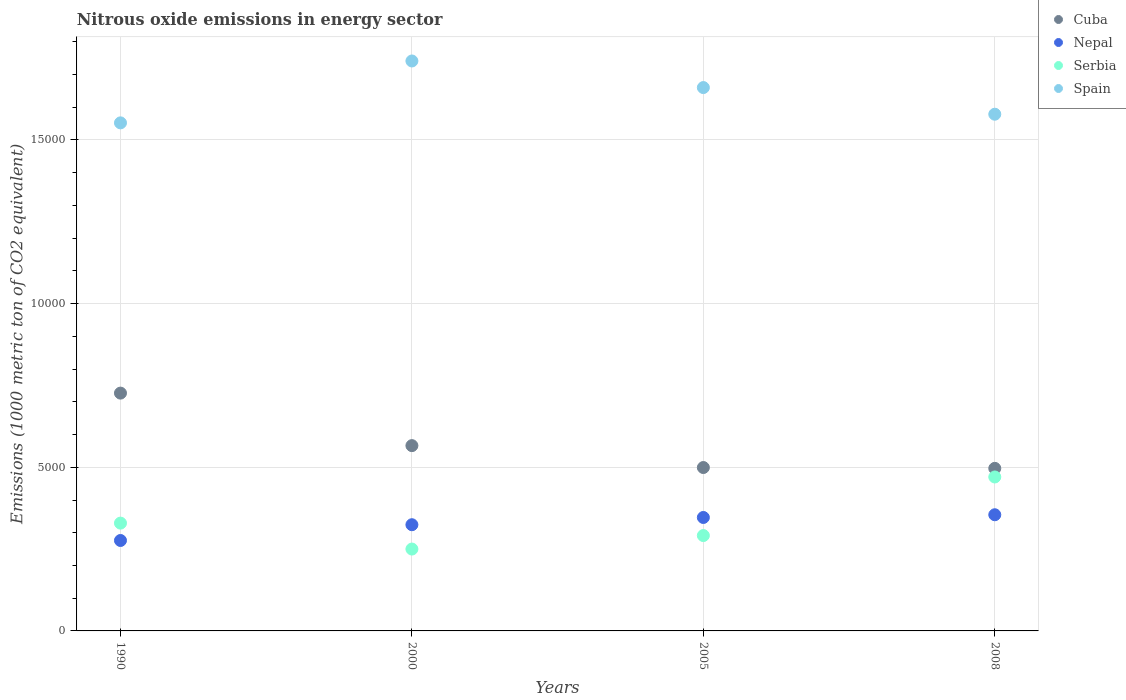How many different coloured dotlines are there?
Provide a succinct answer. 4. What is the amount of nitrous oxide emitted in Spain in 2000?
Your response must be concise. 1.74e+04. Across all years, what is the maximum amount of nitrous oxide emitted in Nepal?
Your response must be concise. 3549.4. Across all years, what is the minimum amount of nitrous oxide emitted in Nepal?
Your answer should be very brief. 2763. In which year was the amount of nitrous oxide emitted in Cuba maximum?
Ensure brevity in your answer.  1990. What is the total amount of nitrous oxide emitted in Cuba in the graph?
Offer a very short reply. 2.29e+04. What is the difference between the amount of nitrous oxide emitted in Serbia in 1990 and that in 2005?
Ensure brevity in your answer.  380. What is the difference between the amount of nitrous oxide emitted in Serbia in 2000 and the amount of nitrous oxide emitted in Spain in 2008?
Ensure brevity in your answer.  -1.33e+04. What is the average amount of nitrous oxide emitted in Serbia per year?
Give a very brief answer. 3353.15. In the year 2008, what is the difference between the amount of nitrous oxide emitted in Nepal and amount of nitrous oxide emitted in Spain?
Provide a succinct answer. -1.22e+04. In how many years, is the amount of nitrous oxide emitted in Nepal greater than 4000 1000 metric ton?
Ensure brevity in your answer.  0. What is the ratio of the amount of nitrous oxide emitted in Cuba in 2000 to that in 2005?
Your answer should be very brief. 1.13. What is the difference between the highest and the second highest amount of nitrous oxide emitted in Spain?
Provide a succinct answer. 812.5. What is the difference between the highest and the lowest amount of nitrous oxide emitted in Cuba?
Provide a succinct answer. 2298.9. In how many years, is the amount of nitrous oxide emitted in Serbia greater than the average amount of nitrous oxide emitted in Serbia taken over all years?
Your answer should be very brief. 1. Is it the case that in every year, the sum of the amount of nitrous oxide emitted in Cuba and amount of nitrous oxide emitted in Spain  is greater than the sum of amount of nitrous oxide emitted in Nepal and amount of nitrous oxide emitted in Serbia?
Your response must be concise. No. Is the amount of nitrous oxide emitted in Serbia strictly less than the amount of nitrous oxide emitted in Spain over the years?
Give a very brief answer. Yes. How many dotlines are there?
Your answer should be very brief. 4. How many years are there in the graph?
Provide a short and direct response. 4. What is the difference between two consecutive major ticks on the Y-axis?
Provide a short and direct response. 5000. Are the values on the major ticks of Y-axis written in scientific E-notation?
Provide a succinct answer. No. Does the graph contain any zero values?
Your answer should be very brief. No. Does the graph contain grids?
Your answer should be very brief. Yes. How many legend labels are there?
Make the answer very short. 4. How are the legend labels stacked?
Provide a succinct answer. Vertical. What is the title of the graph?
Ensure brevity in your answer.  Nitrous oxide emissions in energy sector. Does "Germany" appear as one of the legend labels in the graph?
Your answer should be very brief. No. What is the label or title of the Y-axis?
Ensure brevity in your answer.  Emissions (1000 metric ton of CO2 equivalent). What is the Emissions (1000 metric ton of CO2 equivalent) in Cuba in 1990?
Make the answer very short. 7265.9. What is the Emissions (1000 metric ton of CO2 equivalent) of Nepal in 1990?
Ensure brevity in your answer.  2763. What is the Emissions (1000 metric ton of CO2 equivalent) of Serbia in 1990?
Offer a terse response. 3293.8. What is the Emissions (1000 metric ton of CO2 equivalent) in Spain in 1990?
Your response must be concise. 1.55e+04. What is the Emissions (1000 metric ton of CO2 equivalent) of Cuba in 2000?
Provide a succinct answer. 5661.3. What is the Emissions (1000 metric ton of CO2 equivalent) in Nepal in 2000?
Keep it short and to the point. 3244.8. What is the Emissions (1000 metric ton of CO2 equivalent) of Serbia in 2000?
Offer a terse response. 2501.4. What is the Emissions (1000 metric ton of CO2 equivalent) in Spain in 2000?
Provide a succinct answer. 1.74e+04. What is the Emissions (1000 metric ton of CO2 equivalent) in Cuba in 2005?
Your answer should be very brief. 4992.1. What is the Emissions (1000 metric ton of CO2 equivalent) in Nepal in 2005?
Provide a succinct answer. 3466.2. What is the Emissions (1000 metric ton of CO2 equivalent) of Serbia in 2005?
Your response must be concise. 2913.8. What is the Emissions (1000 metric ton of CO2 equivalent) in Spain in 2005?
Provide a short and direct response. 1.66e+04. What is the Emissions (1000 metric ton of CO2 equivalent) in Cuba in 2008?
Your answer should be very brief. 4967. What is the Emissions (1000 metric ton of CO2 equivalent) of Nepal in 2008?
Offer a very short reply. 3549.4. What is the Emissions (1000 metric ton of CO2 equivalent) in Serbia in 2008?
Your answer should be very brief. 4703.6. What is the Emissions (1000 metric ton of CO2 equivalent) in Spain in 2008?
Give a very brief answer. 1.58e+04. Across all years, what is the maximum Emissions (1000 metric ton of CO2 equivalent) in Cuba?
Your answer should be compact. 7265.9. Across all years, what is the maximum Emissions (1000 metric ton of CO2 equivalent) in Nepal?
Make the answer very short. 3549.4. Across all years, what is the maximum Emissions (1000 metric ton of CO2 equivalent) of Serbia?
Make the answer very short. 4703.6. Across all years, what is the maximum Emissions (1000 metric ton of CO2 equivalent) in Spain?
Your answer should be compact. 1.74e+04. Across all years, what is the minimum Emissions (1000 metric ton of CO2 equivalent) of Cuba?
Your answer should be very brief. 4967. Across all years, what is the minimum Emissions (1000 metric ton of CO2 equivalent) in Nepal?
Keep it short and to the point. 2763. Across all years, what is the minimum Emissions (1000 metric ton of CO2 equivalent) in Serbia?
Offer a very short reply. 2501.4. Across all years, what is the minimum Emissions (1000 metric ton of CO2 equivalent) in Spain?
Keep it short and to the point. 1.55e+04. What is the total Emissions (1000 metric ton of CO2 equivalent) of Cuba in the graph?
Keep it short and to the point. 2.29e+04. What is the total Emissions (1000 metric ton of CO2 equivalent) in Nepal in the graph?
Ensure brevity in your answer.  1.30e+04. What is the total Emissions (1000 metric ton of CO2 equivalent) of Serbia in the graph?
Make the answer very short. 1.34e+04. What is the total Emissions (1000 metric ton of CO2 equivalent) in Spain in the graph?
Your answer should be compact. 6.53e+04. What is the difference between the Emissions (1000 metric ton of CO2 equivalent) of Cuba in 1990 and that in 2000?
Keep it short and to the point. 1604.6. What is the difference between the Emissions (1000 metric ton of CO2 equivalent) of Nepal in 1990 and that in 2000?
Offer a very short reply. -481.8. What is the difference between the Emissions (1000 metric ton of CO2 equivalent) of Serbia in 1990 and that in 2000?
Ensure brevity in your answer.  792.4. What is the difference between the Emissions (1000 metric ton of CO2 equivalent) in Spain in 1990 and that in 2000?
Your answer should be very brief. -1890.8. What is the difference between the Emissions (1000 metric ton of CO2 equivalent) in Cuba in 1990 and that in 2005?
Your response must be concise. 2273.8. What is the difference between the Emissions (1000 metric ton of CO2 equivalent) in Nepal in 1990 and that in 2005?
Make the answer very short. -703.2. What is the difference between the Emissions (1000 metric ton of CO2 equivalent) in Serbia in 1990 and that in 2005?
Give a very brief answer. 380. What is the difference between the Emissions (1000 metric ton of CO2 equivalent) in Spain in 1990 and that in 2005?
Your answer should be very brief. -1078.3. What is the difference between the Emissions (1000 metric ton of CO2 equivalent) of Cuba in 1990 and that in 2008?
Your answer should be compact. 2298.9. What is the difference between the Emissions (1000 metric ton of CO2 equivalent) of Nepal in 1990 and that in 2008?
Provide a short and direct response. -786.4. What is the difference between the Emissions (1000 metric ton of CO2 equivalent) of Serbia in 1990 and that in 2008?
Provide a short and direct response. -1409.8. What is the difference between the Emissions (1000 metric ton of CO2 equivalent) of Spain in 1990 and that in 2008?
Make the answer very short. -264.1. What is the difference between the Emissions (1000 metric ton of CO2 equivalent) of Cuba in 2000 and that in 2005?
Make the answer very short. 669.2. What is the difference between the Emissions (1000 metric ton of CO2 equivalent) in Nepal in 2000 and that in 2005?
Your answer should be compact. -221.4. What is the difference between the Emissions (1000 metric ton of CO2 equivalent) of Serbia in 2000 and that in 2005?
Make the answer very short. -412.4. What is the difference between the Emissions (1000 metric ton of CO2 equivalent) of Spain in 2000 and that in 2005?
Offer a very short reply. 812.5. What is the difference between the Emissions (1000 metric ton of CO2 equivalent) in Cuba in 2000 and that in 2008?
Offer a terse response. 694.3. What is the difference between the Emissions (1000 metric ton of CO2 equivalent) of Nepal in 2000 and that in 2008?
Provide a short and direct response. -304.6. What is the difference between the Emissions (1000 metric ton of CO2 equivalent) of Serbia in 2000 and that in 2008?
Keep it short and to the point. -2202.2. What is the difference between the Emissions (1000 metric ton of CO2 equivalent) of Spain in 2000 and that in 2008?
Keep it short and to the point. 1626.7. What is the difference between the Emissions (1000 metric ton of CO2 equivalent) of Cuba in 2005 and that in 2008?
Ensure brevity in your answer.  25.1. What is the difference between the Emissions (1000 metric ton of CO2 equivalent) of Nepal in 2005 and that in 2008?
Give a very brief answer. -83.2. What is the difference between the Emissions (1000 metric ton of CO2 equivalent) in Serbia in 2005 and that in 2008?
Your answer should be compact. -1789.8. What is the difference between the Emissions (1000 metric ton of CO2 equivalent) of Spain in 2005 and that in 2008?
Offer a terse response. 814.2. What is the difference between the Emissions (1000 metric ton of CO2 equivalent) in Cuba in 1990 and the Emissions (1000 metric ton of CO2 equivalent) in Nepal in 2000?
Offer a terse response. 4021.1. What is the difference between the Emissions (1000 metric ton of CO2 equivalent) of Cuba in 1990 and the Emissions (1000 metric ton of CO2 equivalent) of Serbia in 2000?
Keep it short and to the point. 4764.5. What is the difference between the Emissions (1000 metric ton of CO2 equivalent) of Cuba in 1990 and the Emissions (1000 metric ton of CO2 equivalent) of Spain in 2000?
Provide a short and direct response. -1.01e+04. What is the difference between the Emissions (1000 metric ton of CO2 equivalent) in Nepal in 1990 and the Emissions (1000 metric ton of CO2 equivalent) in Serbia in 2000?
Give a very brief answer. 261.6. What is the difference between the Emissions (1000 metric ton of CO2 equivalent) in Nepal in 1990 and the Emissions (1000 metric ton of CO2 equivalent) in Spain in 2000?
Provide a short and direct response. -1.47e+04. What is the difference between the Emissions (1000 metric ton of CO2 equivalent) in Serbia in 1990 and the Emissions (1000 metric ton of CO2 equivalent) in Spain in 2000?
Make the answer very short. -1.41e+04. What is the difference between the Emissions (1000 metric ton of CO2 equivalent) of Cuba in 1990 and the Emissions (1000 metric ton of CO2 equivalent) of Nepal in 2005?
Your answer should be very brief. 3799.7. What is the difference between the Emissions (1000 metric ton of CO2 equivalent) of Cuba in 1990 and the Emissions (1000 metric ton of CO2 equivalent) of Serbia in 2005?
Ensure brevity in your answer.  4352.1. What is the difference between the Emissions (1000 metric ton of CO2 equivalent) of Cuba in 1990 and the Emissions (1000 metric ton of CO2 equivalent) of Spain in 2005?
Offer a terse response. -9335.4. What is the difference between the Emissions (1000 metric ton of CO2 equivalent) in Nepal in 1990 and the Emissions (1000 metric ton of CO2 equivalent) in Serbia in 2005?
Your response must be concise. -150.8. What is the difference between the Emissions (1000 metric ton of CO2 equivalent) in Nepal in 1990 and the Emissions (1000 metric ton of CO2 equivalent) in Spain in 2005?
Your answer should be compact. -1.38e+04. What is the difference between the Emissions (1000 metric ton of CO2 equivalent) of Serbia in 1990 and the Emissions (1000 metric ton of CO2 equivalent) of Spain in 2005?
Your answer should be very brief. -1.33e+04. What is the difference between the Emissions (1000 metric ton of CO2 equivalent) of Cuba in 1990 and the Emissions (1000 metric ton of CO2 equivalent) of Nepal in 2008?
Make the answer very short. 3716.5. What is the difference between the Emissions (1000 metric ton of CO2 equivalent) in Cuba in 1990 and the Emissions (1000 metric ton of CO2 equivalent) in Serbia in 2008?
Ensure brevity in your answer.  2562.3. What is the difference between the Emissions (1000 metric ton of CO2 equivalent) of Cuba in 1990 and the Emissions (1000 metric ton of CO2 equivalent) of Spain in 2008?
Your answer should be compact. -8521.2. What is the difference between the Emissions (1000 metric ton of CO2 equivalent) in Nepal in 1990 and the Emissions (1000 metric ton of CO2 equivalent) in Serbia in 2008?
Your answer should be compact. -1940.6. What is the difference between the Emissions (1000 metric ton of CO2 equivalent) of Nepal in 1990 and the Emissions (1000 metric ton of CO2 equivalent) of Spain in 2008?
Provide a succinct answer. -1.30e+04. What is the difference between the Emissions (1000 metric ton of CO2 equivalent) in Serbia in 1990 and the Emissions (1000 metric ton of CO2 equivalent) in Spain in 2008?
Your answer should be compact. -1.25e+04. What is the difference between the Emissions (1000 metric ton of CO2 equivalent) of Cuba in 2000 and the Emissions (1000 metric ton of CO2 equivalent) of Nepal in 2005?
Your response must be concise. 2195.1. What is the difference between the Emissions (1000 metric ton of CO2 equivalent) of Cuba in 2000 and the Emissions (1000 metric ton of CO2 equivalent) of Serbia in 2005?
Your response must be concise. 2747.5. What is the difference between the Emissions (1000 metric ton of CO2 equivalent) of Cuba in 2000 and the Emissions (1000 metric ton of CO2 equivalent) of Spain in 2005?
Offer a terse response. -1.09e+04. What is the difference between the Emissions (1000 metric ton of CO2 equivalent) in Nepal in 2000 and the Emissions (1000 metric ton of CO2 equivalent) in Serbia in 2005?
Your answer should be very brief. 331. What is the difference between the Emissions (1000 metric ton of CO2 equivalent) of Nepal in 2000 and the Emissions (1000 metric ton of CO2 equivalent) of Spain in 2005?
Ensure brevity in your answer.  -1.34e+04. What is the difference between the Emissions (1000 metric ton of CO2 equivalent) of Serbia in 2000 and the Emissions (1000 metric ton of CO2 equivalent) of Spain in 2005?
Keep it short and to the point. -1.41e+04. What is the difference between the Emissions (1000 metric ton of CO2 equivalent) of Cuba in 2000 and the Emissions (1000 metric ton of CO2 equivalent) of Nepal in 2008?
Ensure brevity in your answer.  2111.9. What is the difference between the Emissions (1000 metric ton of CO2 equivalent) of Cuba in 2000 and the Emissions (1000 metric ton of CO2 equivalent) of Serbia in 2008?
Your response must be concise. 957.7. What is the difference between the Emissions (1000 metric ton of CO2 equivalent) in Cuba in 2000 and the Emissions (1000 metric ton of CO2 equivalent) in Spain in 2008?
Give a very brief answer. -1.01e+04. What is the difference between the Emissions (1000 metric ton of CO2 equivalent) in Nepal in 2000 and the Emissions (1000 metric ton of CO2 equivalent) in Serbia in 2008?
Give a very brief answer. -1458.8. What is the difference between the Emissions (1000 metric ton of CO2 equivalent) in Nepal in 2000 and the Emissions (1000 metric ton of CO2 equivalent) in Spain in 2008?
Provide a short and direct response. -1.25e+04. What is the difference between the Emissions (1000 metric ton of CO2 equivalent) in Serbia in 2000 and the Emissions (1000 metric ton of CO2 equivalent) in Spain in 2008?
Provide a short and direct response. -1.33e+04. What is the difference between the Emissions (1000 metric ton of CO2 equivalent) of Cuba in 2005 and the Emissions (1000 metric ton of CO2 equivalent) of Nepal in 2008?
Offer a very short reply. 1442.7. What is the difference between the Emissions (1000 metric ton of CO2 equivalent) of Cuba in 2005 and the Emissions (1000 metric ton of CO2 equivalent) of Serbia in 2008?
Provide a succinct answer. 288.5. What is the difference between the Emissions (1000 metric ton of CO2 equivalent) in Cuba in 2005 and the Emissions (1000 metric ton of CO2 equivalent) in Spain in 2008?
Give a very brief answer. -1.08e+04. What is the difference between the Emissions (1000 metric ton of CO2 equivalent) of Nepal in 2005 and the Emissions (1000 metric ton of CO2 equivalent) of Serbia in 2008?
Make the answer very short. -1237.4. What is the difference between the Emissions (1000 metric ton of CO2 equivalent) in Nepal in 2005 and the Emissions (1000 metric ton of CO2 equivalent) in Spain in 2008?
Keep it short and to the point. -1.23e+04. What is the difference between the Emissions (1000 metric ton of CO2 equivalent) of Serbia in 2005 and the Emissions (1000 metric ton of CO2 equivalent) of Spain in 2008?
Ensure brevity in your answer.  -1.29e+04. What is the average Emissions (1000 metric ton of CO2 equivalent) of Cuba per year?
Give a very brief answer. 5721.57. What is the average Emissions (1000 metric ton of CO2 equivalent) in Nepal per year?
Your answer should be very brief. 3255.85. What is the average Emissions (1000 metric ton of CO2 equivalent) in Serbia per year?
Make the answer very short. 3353.15. What is the average Emissions (1000 metric ton of CO2 equivalent) in Spain per year?
Your response must be concise. 1.63e+04. In the year 1990, what is the difference between the Emissions (1000 metric ton of CO2 equivalent) in Cuba and Emissions (1000 metric ton of CO2 equivalent) in Nepal?
Your response must be concise. 4502.9. In the year 1990, what is the difference between the Emissions (1000 metric ton of CO2 equivalent) in Cuba and Emissions (1000 metric ton of CO2 equivalent) in Serbia?
Provide a succinct answer. 3972.1. In the year 1990, what is the difference between the Emissions (1000 metric ton of CO2 equivalent) in Cuba and Emissions (1000 metric ton of CO2 equivalent) in Spain?
Keep it short and to the point. -8257.1. In the year 1990, what is the difference between the Emissions (1000 metric ton of CO2 equivalent) of Nepal and Emissions (1000 metric ton of CO2 equivalent) of Serbia?
Give a very brief answer. -530.8. In the year 1990, what is the difference between the Emissions (1000 metric ton of CO2 equivalent) of Nepal and Emissions (1000 metric ton of CO2 equivalent) of Spain?
Your answer should be very brief. -1.28e+04. In the year 1990, what is the difference between the Emissions (1000 metric ton of CO2 equivalent) of Serbia and Emissions (1000 metric ton of CO2 equivalent) of Spain?
Your answer should be very brief. -1.22e+04. In the year 2000, what is the difference between the Emissions (1000 metric ton of CO2 equivalent) in Cuba and Emissions (1000 metric ton of CO2 equivalent) in Nepal?
Your answer should be compact. 2416.5. In the year 2000, what is the difference between the Emissions (1000 metric ton of CO2 equivalent) of Cuba and Emissions (1000 metric ton of CO2 equivalent) of Serbia?
Offer a terse response. 3159.9. In the year 2000, what is the difference between the Emissions (1000 metric ton of CO2 equivalent) of Cuba and Emissions (1000 metric ton of CO2 equivalent) of Spain?
Provide a short and direct response. -1.18e+04. In the year 2000, what is the difference between the Emissions (1000 metric ton of CO2 equivalent) of Nepal and Emissions (1000 metric ton of CO2 equivalent) of Serbia?
Provide a short and direct response. 743.4. In the year 2000, what is the difference between the Emissions (1000 metric ton of CO2 equivalent) of Nepal and Emissions (1000 metric ton of CO2 equivalent) of Spain?
Keep it short and to the point. -1.42e+04. In the year 2000, what is the difference between the Emissions (1000 metric ton of CO2 equivalent) in Serbia and Emissions (1000 metric ton of CO2 equivalent) in Spain?
Offer a terse response. -1.49e+04. In the year 2005, what is the difference between the Emissions (1000 metric ton of CO2 equivalent) of Cuba and Emissions (1000 metric ton of CO2 equivalent) of Nepal?
Give a very brief answer. 1525.9. In the year 2005, what is the difference between the Emissions (1000 metric ton of CO2 equivalent) in Cuba and Emissions (1000 metric ton of CO2 equivalent) in Serbia?
Your answer should be compact. 2078.3. In the year 2005, what is the difference between the Emissions (1000 metric ton of CO2 equivalent) of Cuba and Emissions (1000 metric ton of CO2 equivalent) of Spain?
Your answer should be compact. -1.16e+04. In the year 2005, what is the difference between the Emissions (1000 metric ton of CO2 equivalent) of Nepal and Emissions (1000 metric ton of CO2 equivalent) of Serbia?
Offer a very short reply. 552.4. In the year 2005, what is the difference between the Emissions (1000 metric ton of CO2 equivalent) in Nepal and Emissions (1000 metric ton of CO2 equivalent) in Spain?
Give a very brief answer. -1.31e+04. In the year 2005, what is the difference between the Emissions (1000 metric ton of CO2 equivalent) of Serbia and Emissions (1000 metric ton of CO2 equivalent) of Spain?
Ensure brevity in your answer.  -1.37e+04. In the year 2008, what is the difference between the Emissions (1000 metric ton of CO2 equivalent) of Cuba and Emissions (1000 metric ton of CO2 equivalent) of Nepal?
Ensure brevity in your answer.  1417.6. In the year 2008, what is the difference between the Emissions (1000 metric ton of CO2 equivalent) of Cuba and Emissions (1000 metric ton of CO2 equivalent) of Serbia?
Keep it short and to the point. 263.4. In the year 2008, what is the difference between the Emissions (1000 metric ton of CO2 equivalent) in Cuba and Emissions (1000 metric ton of CO2 equivalent) in Spain?
Keep it short and to the point. -1.08e+04. In the year 2008, what is the difference between the Emissions (1000 metric ton of CO2 equivalent) in Nepal and Emissions (1000 metric ton of CO2 equivalent) in Serbia?
Provide a short and direct response. -1154.2. In the year 2008, what is the difference between the Emissions (1000 metric ton of CO2 equivalent) of Nepal and Emissions (1000 metric ton of CO2 equivalent) of Spain?
Give a very brief answer. -1.22e+04. In the year 2008, what is the difference between the Emissions (1000 metric ton of CO2 equivalent) in Serbia and Emissions (1000 metric ton of CO2 equivalent) in Spain?
Give a very brief answer. -1.11e+04. What is the ratio of the Emissions (1000 metric ton of CO2 equivalent) of Cuba in 1990 to that in 2000?
Your answer should be very brief. 1.28. What is the ratio of the Emissions (1000 metric ton of CO2 equivalent) in Nepal in 1990 to that in 2000?
Give a very brief answer. 0.85. What is the ratio of the Emissions (1000 metric ton of CO2 equivalent) of Serbia in 1990 to that in 2000?
Keep it short and to the point. 1.32. What is the ratio of the Emissions (1000 metric ton of CO2 equivalent) of Spain in 1990 to that in 2000?
Ensure brevity in your answer.  0.89. What is the ratio of the Emissions (1000 metric ton of CO2 equivalent) in Cuba in 1990 to that in 2005?
Make the answer very short. 1.46. What is the ratio of the Emissions (1000 metric ton of CO2 equivalent) in Nepal in 1990 to that in 2005?
Give a very brief answer. 0.8. What is the ratio of the Emissions (1000 metric ton of CO2 equivalent) of Serbia in 1990 to that in 2005?
Offer a terse response. 1.13. What is the ratio of the Emissions (1000 metric ton of CO2 equivalent) of Spain in 1990 to that in 2005?
Provide a short and direct response. 0.94. What is the ratio of the Emissions (1000 metric ton of CO2 equivalent) in Cuba in 1990 to that in 2008?
Offer a terse response. 1.46. What is the ratio of the Emissions (1000 metric ton of CO2 equivalent) in Nepal in 1990 to that in 2008?
Offer a very short reply. 0.78. What is the ratio of the Emissions (1000 metric ton of CO2 equivalent) of Serbia in 1990 to that in 2008?
Make the answer very short. 0.7. What is the ratio of the Emissions (1000 metric ton of CO2 equivalent) in Spain in 1990 to that in 2008?
Your answer should be very brief. 0.98. What is the ratio of the Emissions (1000 metric ton of CO2 equivalent) in Cuba in 2000 to that in 2005?
Keep it short and to the point. 1.13. What is the ratio of the Emissions (1000 metric ton of CO2 equivalent) in Nepal in 2000 to that in 2005?
Give a very brief answer. 0.94. What is the ratio of the Emissions (1000 metric ton of CO2 equivalent) in Serbia in 2000 to that in 2005?
Provide a succinct answer. 0.86. What is the ratio of the Emissions (1000 metric ton of CO2 equivalent) of Spain in 2000 to that in 2005?
Offer a very short reply. 1.05. What is the ratio of the Emissions (1000 metric ton of CO2 equivalent) in Cuba in 2000 to that in 2008?
Keep it short and to the point. 1.14. What is the ratio of the Emissions (1000 metric ton of CO2 equivalent) in Nepal in 2000 to that in 2008?
Your response must be concise. 0.91. What is the ratio of the Emissions (1000 metric ton of CO2 equivalent) in Serbia in 2000 to that in 2008?
Provide a short and direct response. 0.53. What is the ratio of the Emissions (1000 metric ton of CO2 equivalent) in Spain in 2000 to that in 2008?
Provide a short and direct response. 1.1. What is the ratio of the Emissions (1000 metric ton of CO2 equivalent) in Cuba in 2005 to that in 2008?
Ensure brevity in your answer.  1.01. What is the ratio of the Emissions (1000 metric ton of CO2 equivalent) in Nepal in 2005 to that in 2008?
Make the answer very short. 0.98. What is the ratio of the Emissions (1000 metric ton of CO2 equivalent) in Serbia in 2005 to that in 2008?
Your answer should be very brief. 0.62. What is the ratio of the Emissions (1000 metric ton of CO2 equivalent) in Spain in 2005 to that in 2008?
Provide a short and direct response. 1.05. What is the difference between the highest and the second highest Emissions (1000 metric ton of CO2 equivalent) of Cuba?
Provide a short and direct response. 1604.6. What is the difference between the highest and the second highest Emissions (1000 metric ton of CO2 equivalent) in Nepal?
Provide a short and direct response. 83.2. What is the difference between the highest and the second highest Emissions (1000 metric ton of CO2 equivalent) in Serbia?
Ensure brevity in your answer.  1409.8. What is the difference between the highest and the second highest Emissions (1000 metric ton of CO2 equivalent) of Spain?
Make the answer very short. 812.5. What is the difference between the highest and the lowest Emissions (1000 metric ton of CO2 equivalent) in Cuba?
Your response must be concise. 2298.9. What is the difference between the highest and the lowest Emissions (1000 metric ton of CO2 equivalent) of Nepal?
Keep it short and to the point. 786.4. What is the difference between the highest and the lowest Emissions (1000 metric ton of CO2 equivalent) in Serbia?
Your answer should be very brief. 2202.2. What is the difference between the highest and the lowest Emissions (1000 metric ton of CO2 equivalent) of Spain?
Offer a very short reply. 1890.8. 